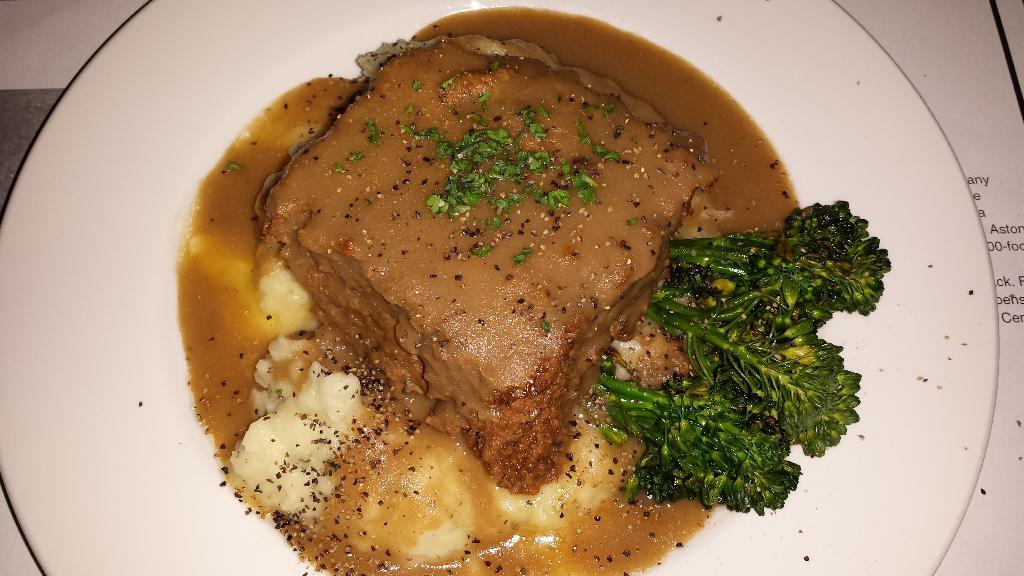What can be seen in the image? There are food items in the image. How are the food items arranged or presented? The food items are placed on a white plate. What type of cap is visible on the food items in the image? There is no cap present on the food items in the image. Can you see any veins in the food items in the image? The image does not show any veins, as it features food items on a plate. What kind of amusement can be found in the image? There is no amusement present in the image; it only contains food items on a white plate. 